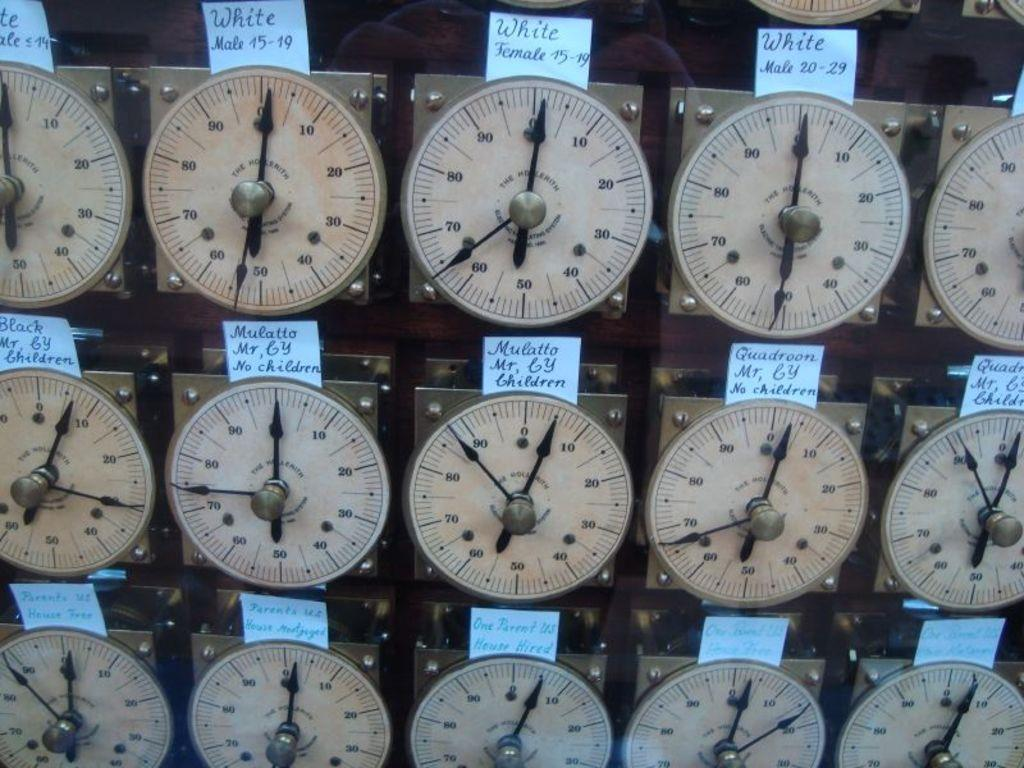<image>
Create a compact narrative representing the image presented. A series of dials with labels detailing the occupants of the rooms the dials relate to. 